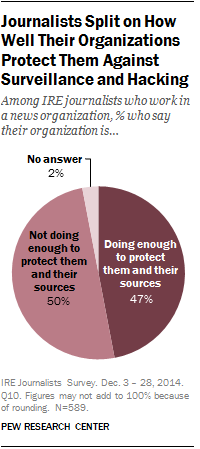Outline some significant characteristics in this image. The value of the largest segment is 50. The sum of the smallest and second largest segments is not equal to the largest segment value. 